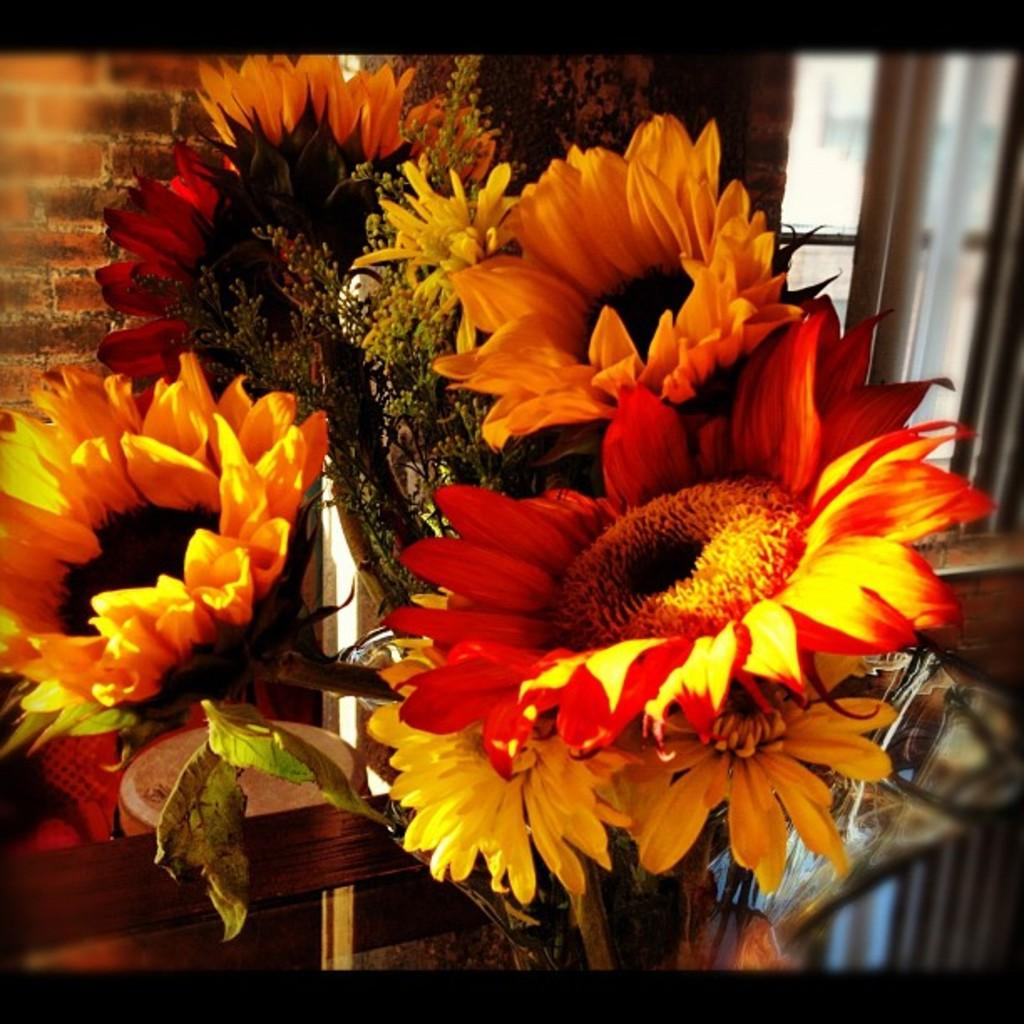What is in the vase that is visible in the image? There are flowers in a vase in the image. How would you describe the background of the image? The background of the image is blurry. What type of architectural feature can be seen in the background of the image? There is a wall in the background of the image. Is there any natural light source visible in the image? Yes, there is a window in the background of the image. What type of trains can be seen passing by in the image? There are no trains present in the image; it features flowers in a vase with a blurry background and a wall and window in the background. 